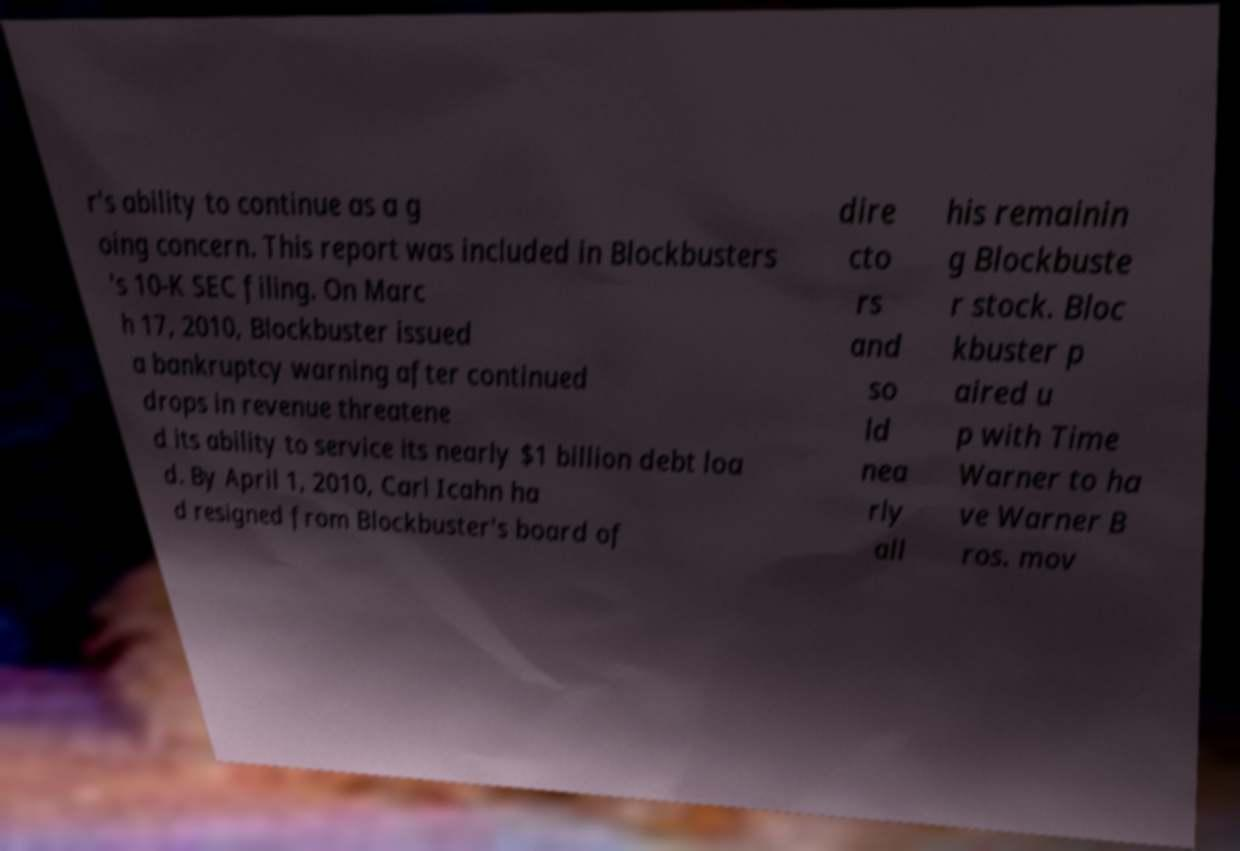Can you read and provide the text displayed in the image?This photo seems to have some interesting text. Can you extract and type it out for me? r's ability to continue as a g oing concern. This report was included in Blockbusters 's 10-K SEC filing. On Marc h 17, 2010, Blockbuster issued a bankruptcy warning after continued drops in revenue threatene d its ability to service its nearly $1 billion debt loa d. By April 1, 2010, Carl Icahn ha d resigned from Blockbuster's board of dire cto rs and so ld nea rly all his remainin g Blockbuste r stock. Bloc kbuster p aired u p with Time Warner to ha ve Warner B ros. mov 